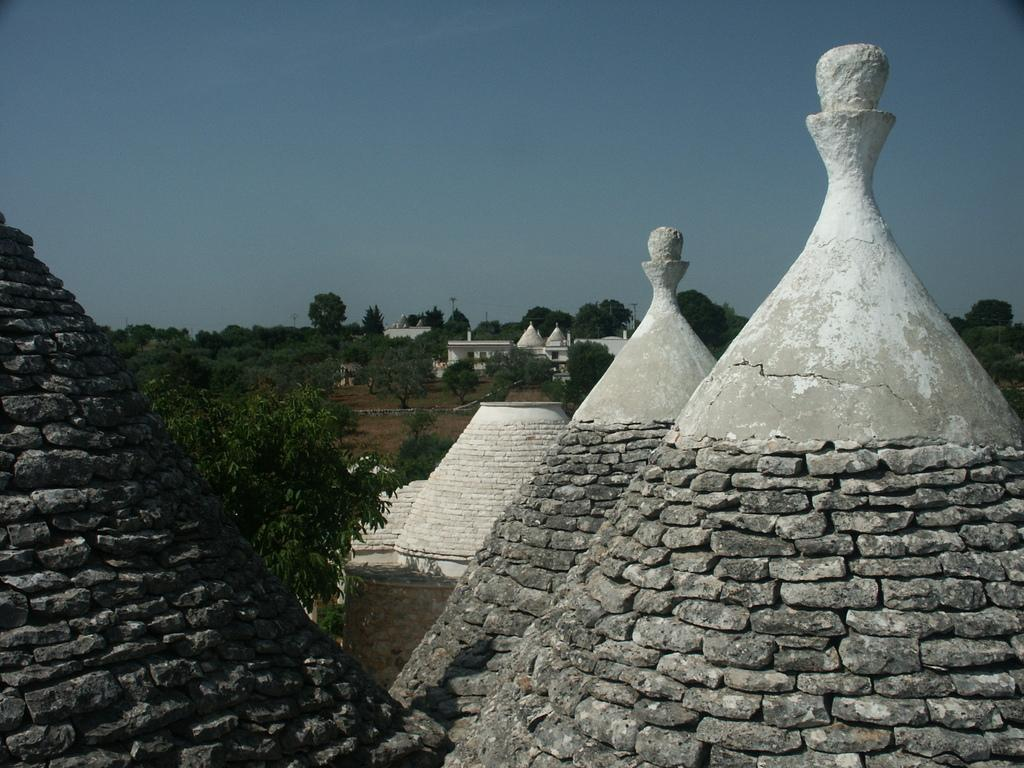What type of material is used to construct the buildings in the image? The buildings in the image are made with stones. What can be seen in the background of the image? There is a group of trees and at least one building in the background of the image. What part of the natural environment is visible in the image? The sky is visible in the background of the image. How many lamps are hanging from the trees in the image? There are no lamps hanging from the trees in the image. 